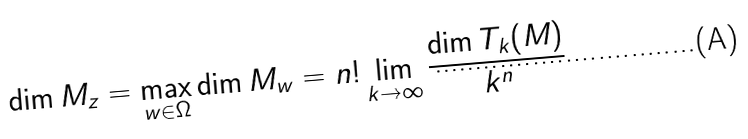<formula> <loc_0><loc_0><loc_500><loc_500>\dim M _ { z } = \max _ { w \in \Omega } \dim M _ { w } = n ! \lim _ { k \rightarrow \infty } \frac { \dim T _ { k } ( M ) } { k ^ { n } }</formula> 